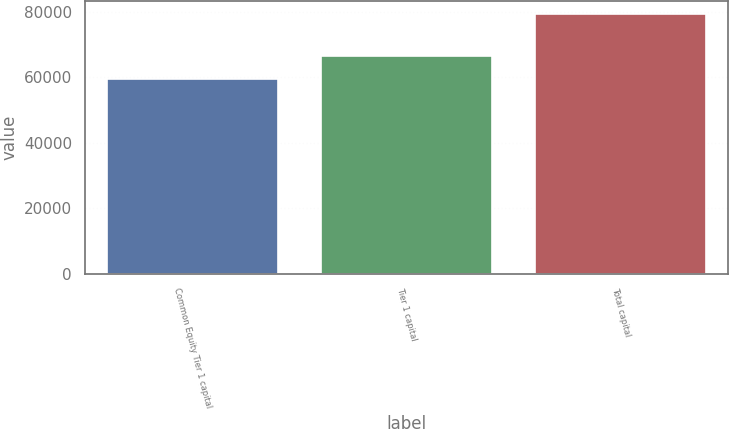<chart> <loc_0><loc_0><loc_500><loc_500><bar_chart><fcel>Common Equity Tier 1 capital<fcel>Tier 1 capital<fcel>Total capital<nl><fcel>59409<fcel>66722<fcel>79403<nl></chart> 